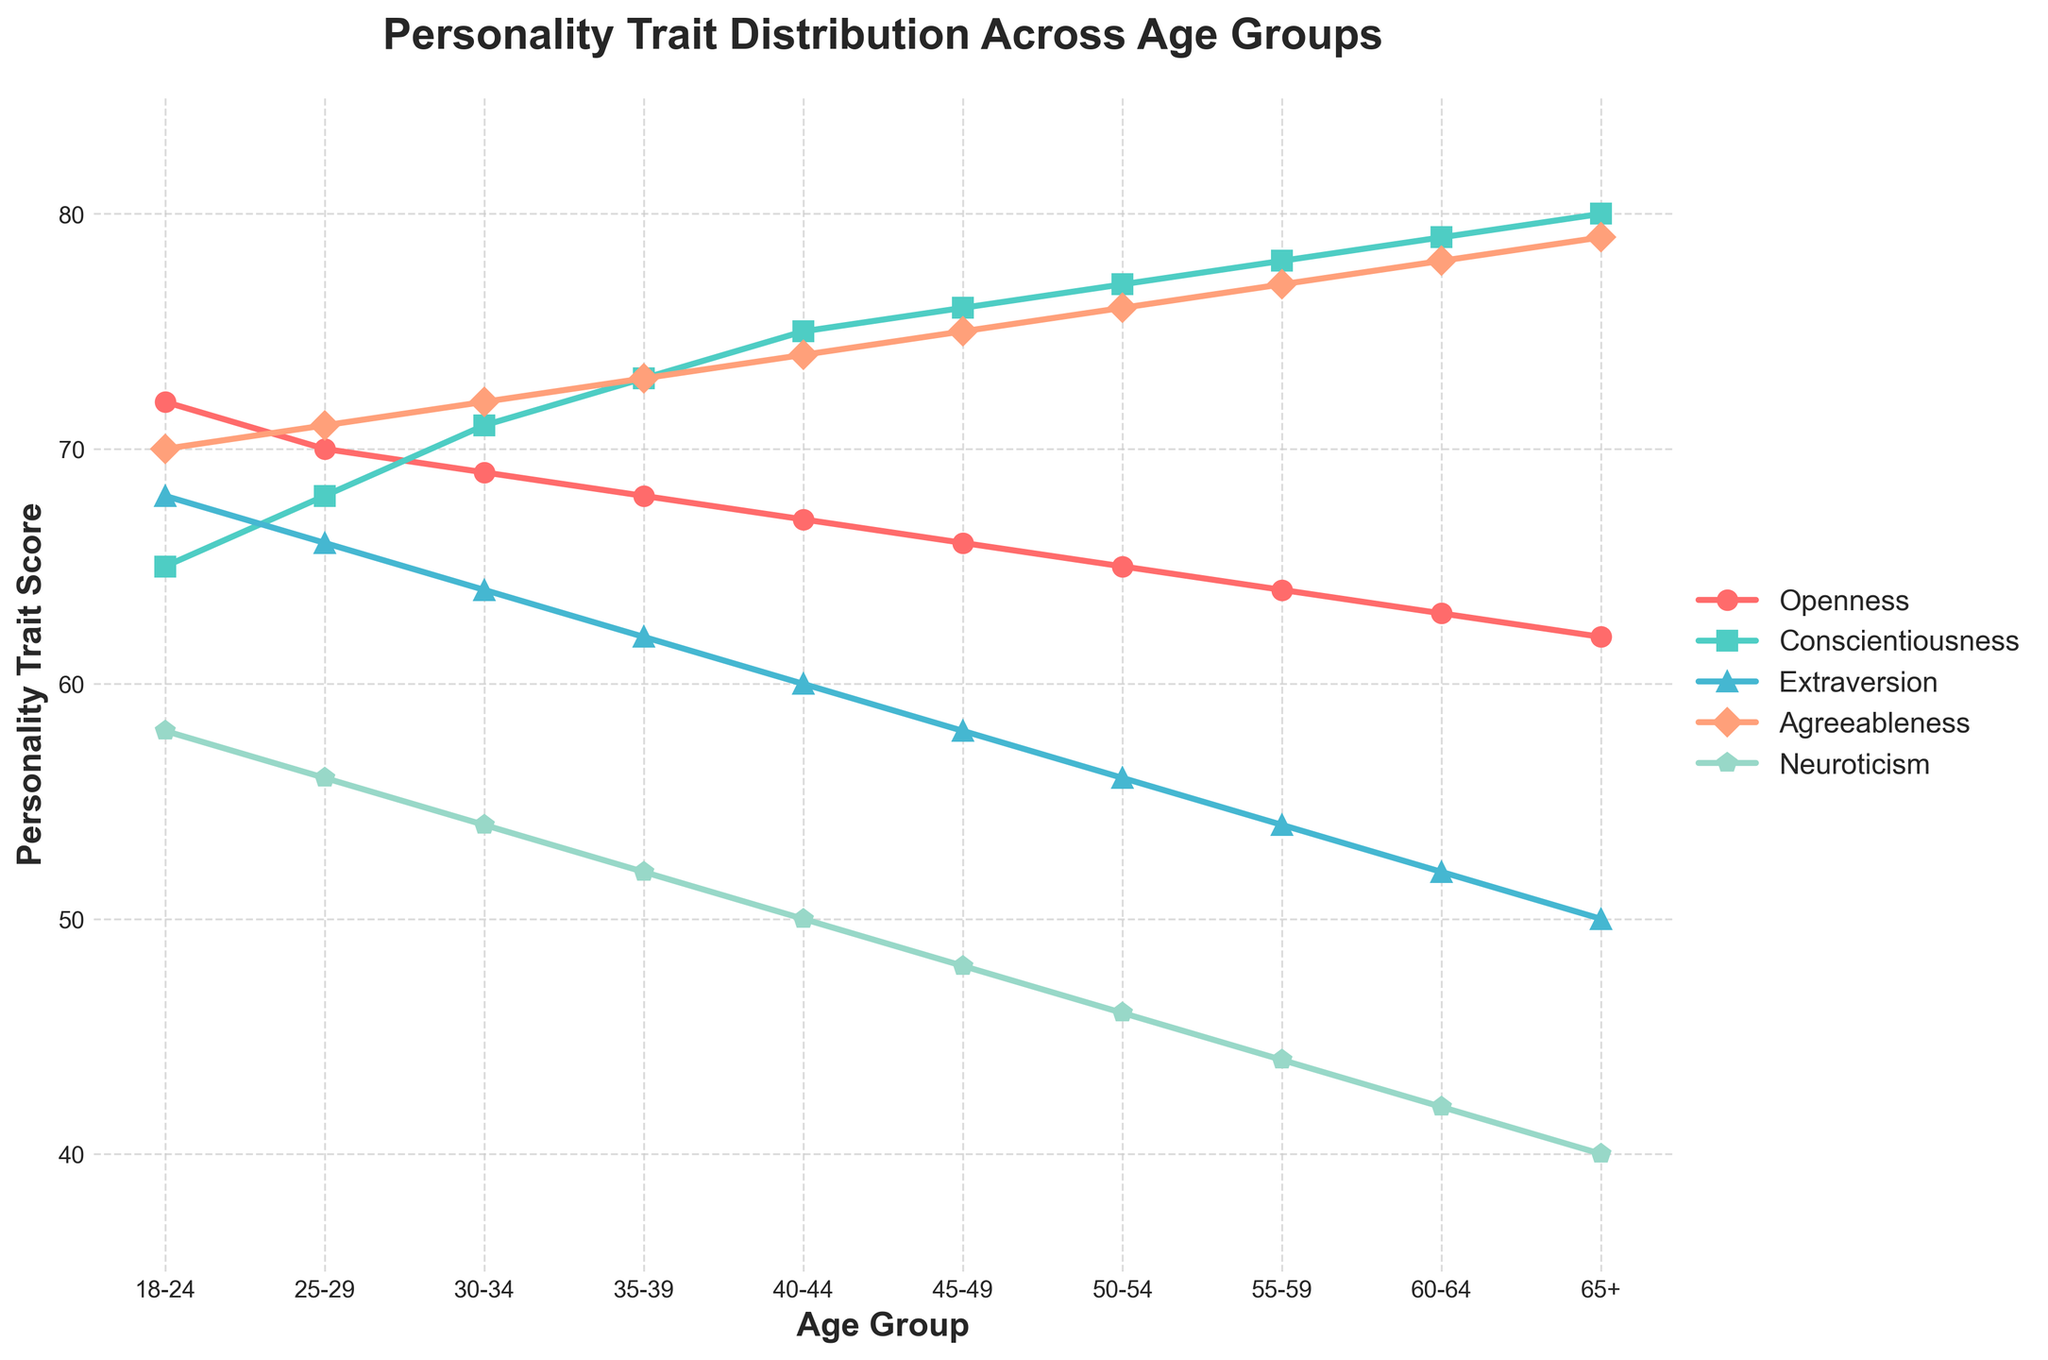What age group has the highest score for Conscientiousness? The green line with square markers shows Conscientiousness scores. The highest point on this line is at the "65+" age group.
Answer: 65+ Which age groups have an Agreeableness score of exactly 75 or higher? The orange line with diamond markers represents Agreeableness. Starting from the "45-49" age group and upwards, all points are 75 or higher.
Answer: 45-49 and older By how much does Extraversion decrease from the 18-24 age group to the 65+ age group? The blue line with triangle markers shows Extraversion. At 18-24, the score is 68, and at 65+, it is 50. The difference is 68 - 50 = 18 points.
Answer: 18 What is the average Neuroticism score for the age groups 30-34, 35-39, and 40-44? The purple line with pentagon markers shows Neuroticism. The scores for these age groups are 54, 52, and 50 respectively. The average is (54 + 52 + 50) / 3 = 52.
Answer: 52 For which trait does the 60-64 age group have the lowest score? Observing all lines at the 60-64 age mark, the lowest point appears on the blue line representing Extraversion with a score of 52.
Answer: Extraversion What is the trend of Agreeableness scores as the age increases? The orange line with diamond markers shows an increasing trend in Agreeableness scores from 18-24 (70) to 65+ (79).
Answer: Increasing By how much does Conscientiousness score increase from the 18-24 to the 60-64 age group? The green line with square markers shows Conscientiousness. At 18-24, the score is 65, and at 60-64, it is 79. The increase is 79 - 65 = 14 points.
Answer: 14 Compare the Extraversion and Agreeableness scores for the 50-54 age group. Which one is higher? The blue line with triangle markers indicates Extraversion and shows 56 at 50-54; the orange line with diamond markers indicates Agreeableness and shows 76 at the same age. Agreeableness is higher.
Answer: Agreeableness What is the sum of Openness scores for the 45-49, 50-54, and 55-59 age groups? The red line with circle markers shows Openness. The scores are 66, 65, and 64 respectively. The sum is 66 + 65 + 64 = 195.
Answer: 195 Does the Neuroticism score trend upward or downward with increasing age? The purple line with pentagon markers shows a downward trend in Neuroticism scores as age increases, starting from 58 at 18-24 to 40 at 65+.
Answer: Downward 